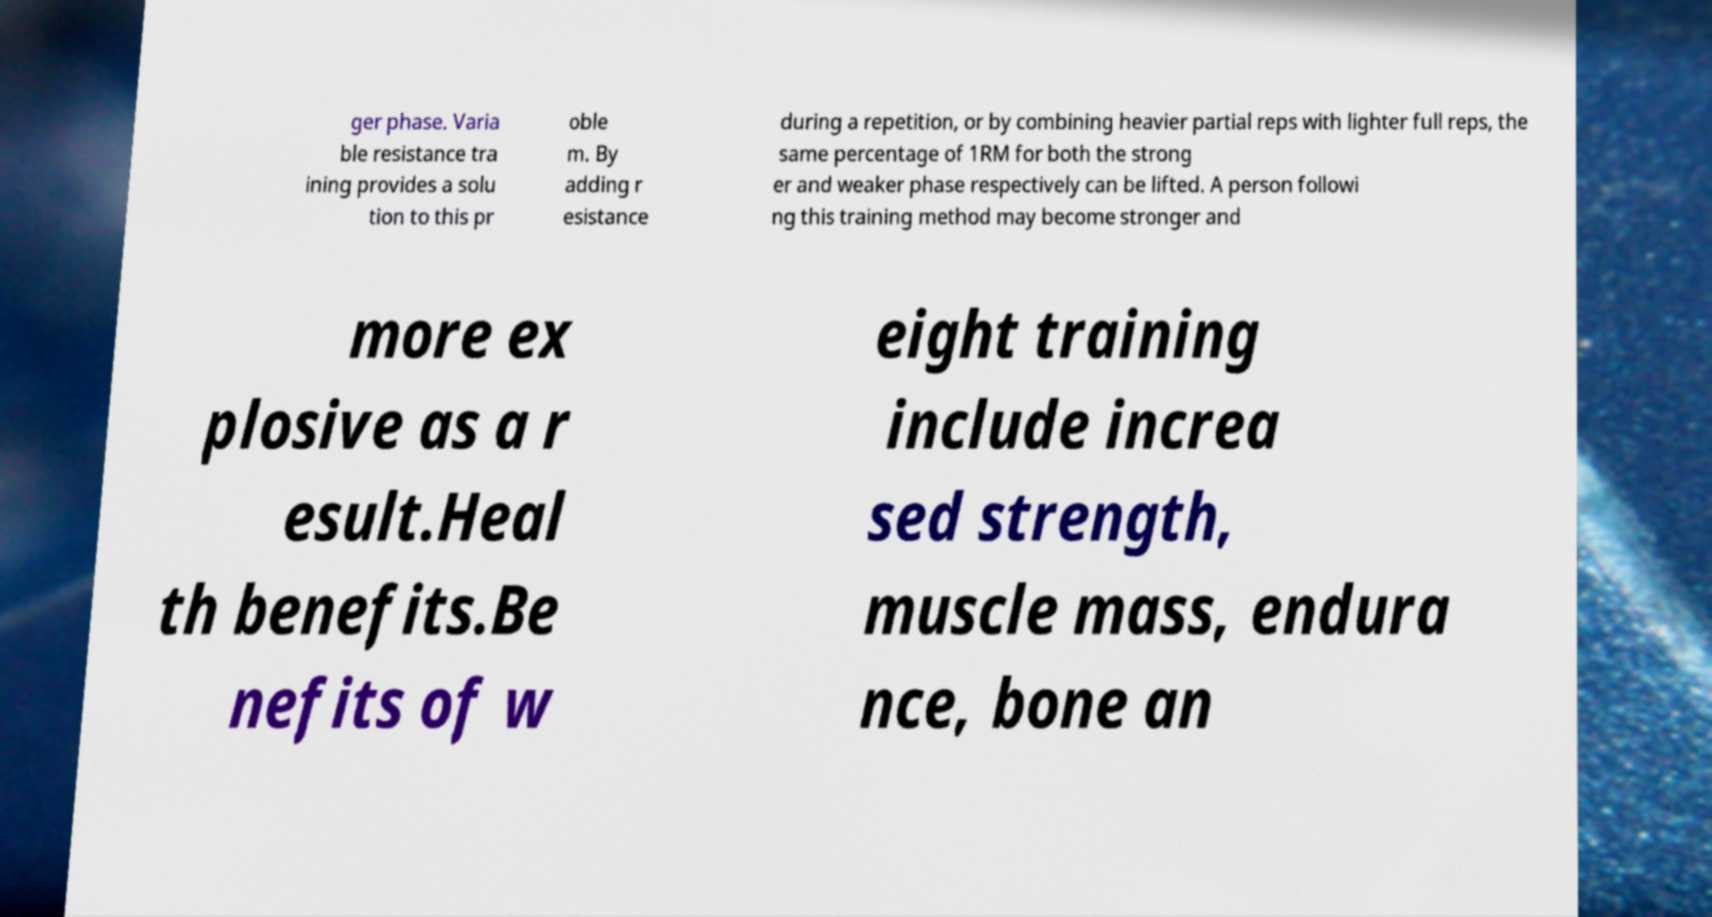Please identify and transcribe the text found in this image. ger phase. Varia ble resistance tra ining provides a solu tion to this pr oble m. By adding r esistance during a repetition, or by combining heavier partial reps with lighter full reps, the same percentage of 1RM for both the strong er and weaker phase respectively can be lifted. A person followi ng this training method may become stronger and more ex plosive as a r esult.Heal th benefits.Be nefits of w eight training include increa sed strength, muscle mass, endura nce, bone an 